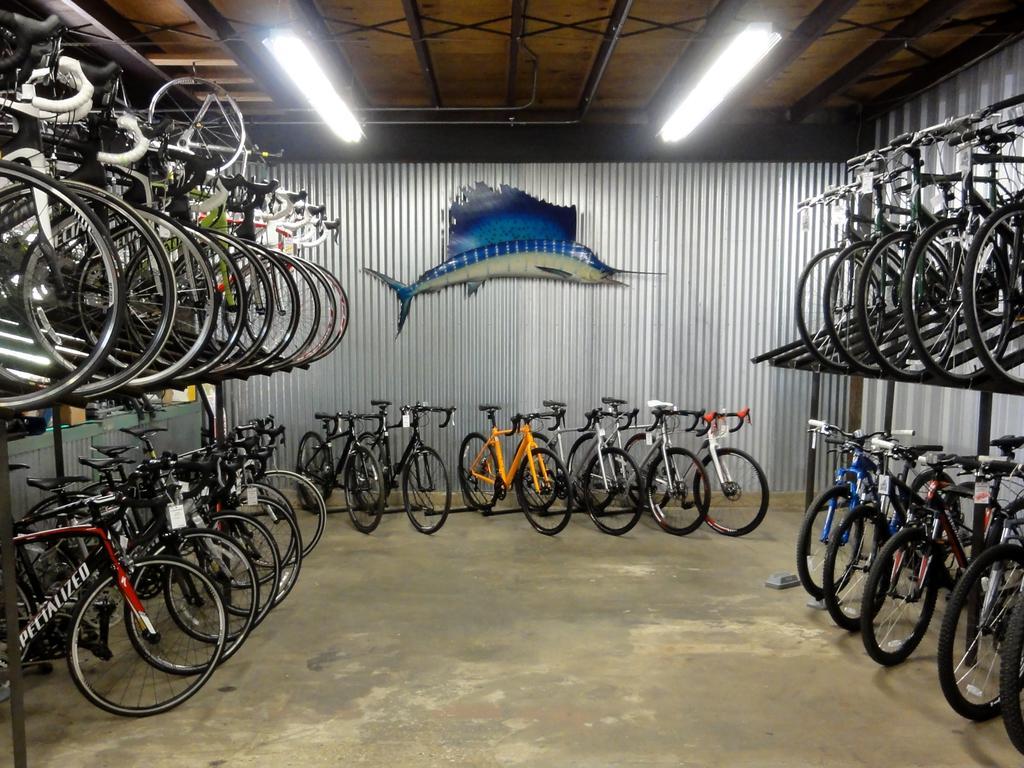Can you describe this image briefly? In this picture I can see there are many bicycles parked here and among them there is a red and black frame bicycle and there is a yellow color bicycle at the center and there is a blue color bicycle at the right and there is a symbol of a fish in the backdrop wall and there are lights attached to the ceiling. 